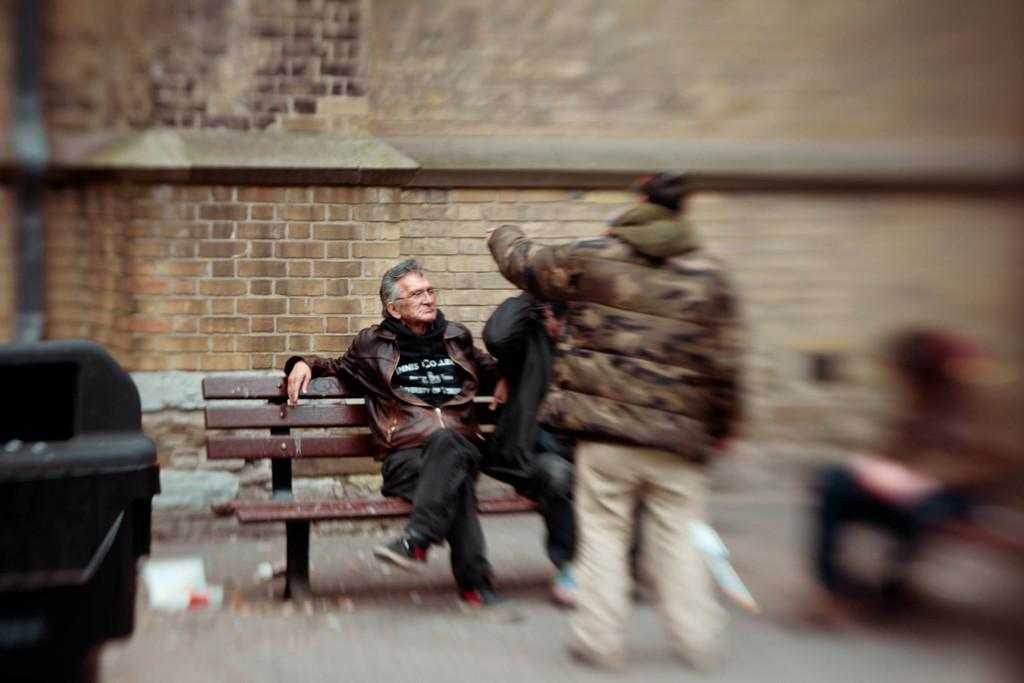Who is the main subject in the image? There is an old man in the image. What is the old man doing in the image? The old man is sitting on a bench. What can be seen in the background of the image? There is a brick wall in the image. Are there any other people in the image besides the old man? Yes, people are present beside the old man, but they are out of focus. What type of egg is being served on the oatmeal in the image? There is no egg or oatmeal present in the image; it features an old man sitting on a bench with a brick wall in the background. 